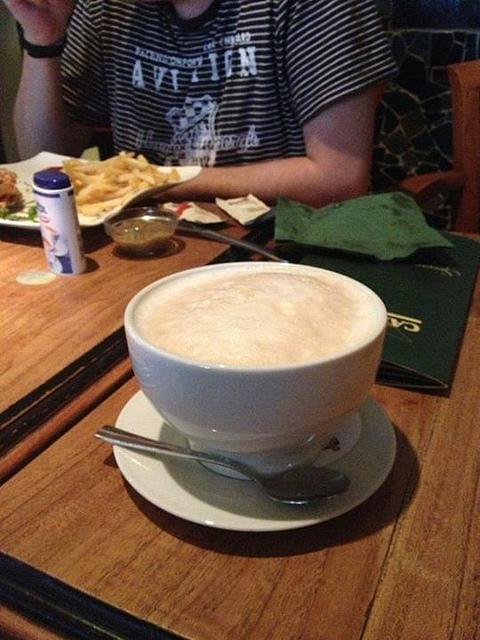How many tables are in this pic?
Give a very brief answer. 2. How many bowls can you see?
Give a very brief answer. 2. 